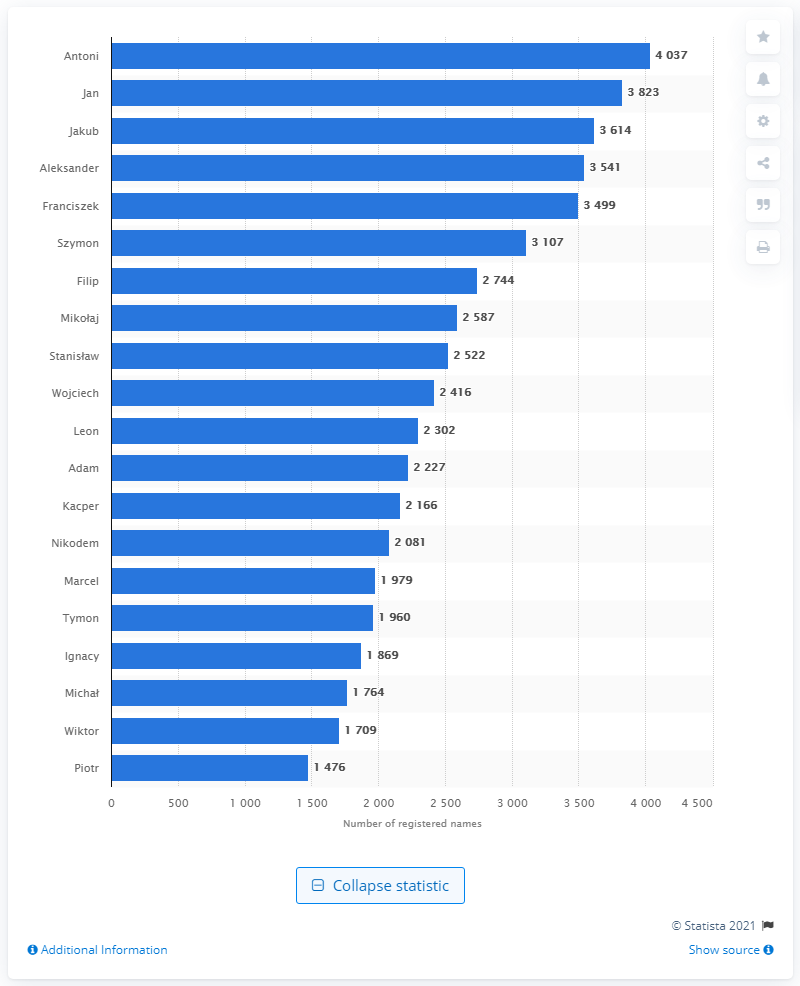Point out several critical features in this image. According to data collected in the first half of 2020, the most common male first name given to children in Poland was Antoni. 